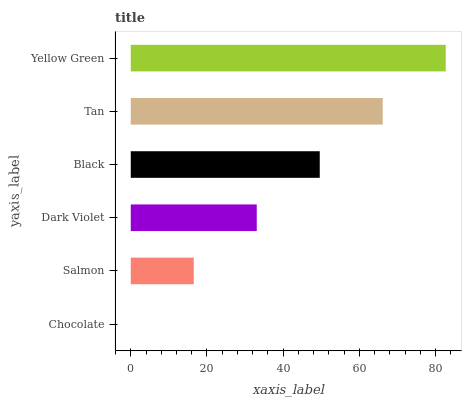Is Chocolate the minimum?
Answer yes or no. Yes. Is Yellow Green the maximum?
Answer yes or no. Yes. Is Salmon the minimum?
Answer yes or no. No. Is Salmon the maximum?
Answer yes or no. No. Is Salmon greater than Chocolate?
Answer yes or no. Yes. Is Chocolate less than Salmon?
Answer yes or no. Yes. Is Chocolate greater than Salmon?
Answer yes or no. No. Is Salmon less than Chocolate?
Answer yes or no. No. Is Black the high median?
Answer yes or no. Yes. Is Dark Violet the low median?
Answer yes or no. Yes. Is Dark Violet the high median?
Answer yes or no. No. Is Salmon the low median?
Answer yes or no. No. 